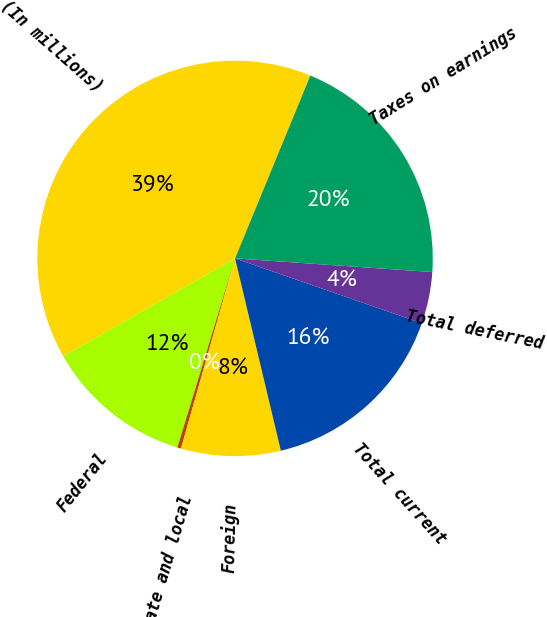Convert chart. <chart><loc_0><loc_0><loc_500><loc_500><pie_chart><fcel>(In millions)<fcel>Federal<fcel>State and local<fcel>Foreign<fcel>Total current<fcel>Total deferred<fcel>Taxes on earnings<nl><fcel>39.45%<fcel>12.05%<fcel>0.3%<fcel>8.13%<fcel>15.96%<fcel>4.22%<fcel>19.88%<nl></chart> 